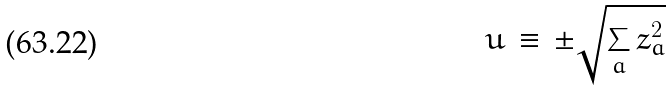Convert formula to latex. <formula><loc_0><loc_0><loc_500><loc_500>u \, \equiv \, \pm \sqrt { \sum _ { a } z _ { a } ^ { 2 } }</formula> 